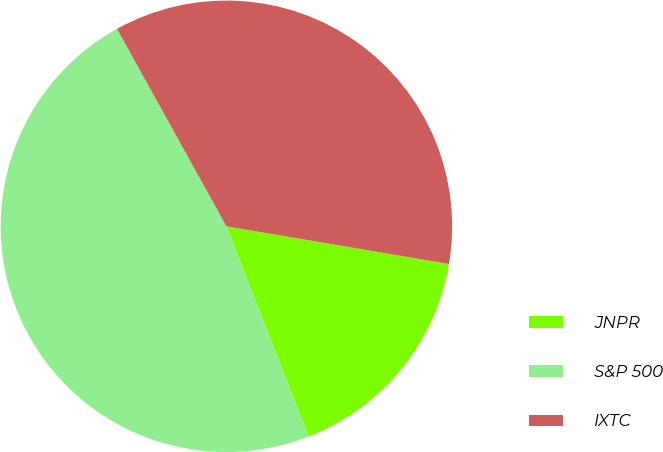Convert chart to OTSL. <chart><loc_0><loc_0><loc_500><loc_500><pie_chart><fcel>JNPR<fcel>S&P 500<fcel>IXTC<nl><fcel>16.39%<fcel>47.88%<fcel>35.73%<nl></chart> 